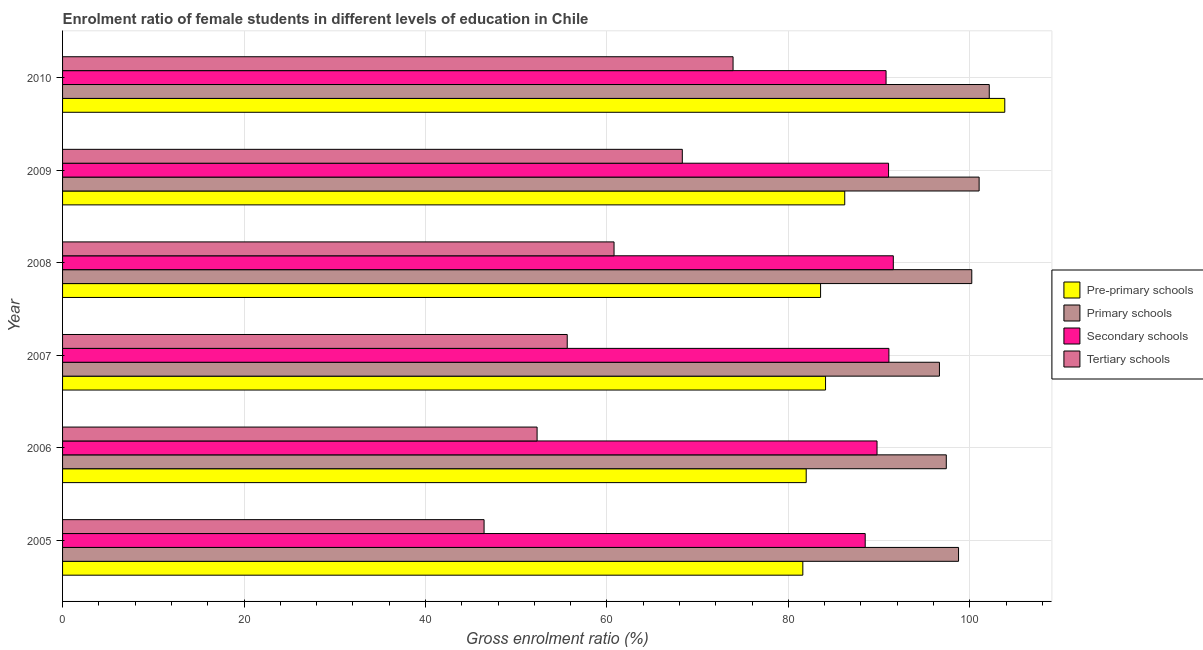Are the number of bars per tick equal to the number of legend labels?
Keep it short and to the point. Yes. How many bars are there on the 4th tick from the top?
Offer a very short reply. 4. What is the label of the 1st group of bars from the top?
Make the answer very short. 2010. In how many cases, is the number of bars for a given year not equal to the number of legend labels?
Your answer should be very brief. 0. What is the gross enrolment ratio(male) in pre-primary schools in 2006?
Give a very brief answer. 81.97. Across all years, what is the maximum gross enrolment ratio(male) in primary schools?
Keep it short and to the point. 102.15. Across all years, what is the minimum gross enrolment ratio(male) in primary schools?
Make the answer very short. 96.66. In which year was the gross enrolment ratio(male) in tertiary schools maximum?
Your answer should be very brief. 2010. In which year was the gross enrolment ratio(male) in secondary schools minimum?
Ensure brevity in your answer.  2005. What is the total gross enrolment ratio(male) in primary schools in the graph?
Give a very brief answer. 596.23. What is the difference between the gross enrolment ratio(male) in primary schools in 2005 and that in 2006?
Offer a very short reply. 1.35. What is the difference between the gross enrolment ratio(male) in secondary schools in 2005 and the gross enrolment ratio(male) in primary schools in 2010?
Offer a very short reply. -13.68. What is the average gross enrolment ratio(male) in tertiary schools per year?
Offer a very short reply. 59.57. In the year 2007, what is the difference between the gross enrolment ratio(male) in primary schools and gross enrolment ratio(male) in secondary schools?
Give a very brief answer. 5.57. What is the ratio of the gross enrolment ratio(male) in tertiary schools in 2005 to that in 2008?
Offer a terse response. 0.76. Is the difference between the gross enrolment ratio(male) in tertiary schools in 2008 and 2009 greater than the difference between the gross enrolment ratio(male) in primary schools in 2008 and 2009?
Provide a succinct answer. No. What is the difference between the highest and the second highest gross enrolment ratio(male) in pre-primary schools?
Your answer should be compact. 17.64. What is the difference between the highest and the lowest gross enrolment ratio(male) in tertiary schools?
Offer a very short reply. 27.44. In how many years, is the gross enrolment ratio(male) in secondary schools greater than the average gross enrolment ratio(male) in secondary schools taken over all years?
Offer a very short reply. 4. What does the 1st bar from the top in 2007 represents?
Offer a terse response. Tertiary schools. What does the 1st bar from the bottom in 2008 represents?
Your answer should be very brief. Pre-primary schools. How many years are there in the graph?
Keep it short and to the point. 6. What is the difference between two consecutive major ticks on the X-axis?
Your answer should be very brief. 20. Does the graph contain any zero values?
Your answer should be compact. No. How many legend labels are there?
Your answer should be compact. 4. How are the legend labels stacked?
Offer a terse response. Vertical. What is the title of the graph?
Ensure brevity in your answer.  Enrolment ratio of female students in different levels of education in Chile. Does "Revenue mobilization" appear as one of the legend labels in the graph?
Offer a very short reply. No. What is the label or title of the X-axis?
Your answer should be very brief. Gross enrolment ratio (%). What is the label or title of the Y-axis?
Offer a terse response. Year. What is the Gross enrolment ratio (%) of Pre-primary schools in 2005?
Your response must be concise. 81.6. What is the Gross enrolment ratio (%) in Primary schools in 2005?
Offer a very short reply. 98.76. What is the Gross enrolment ratio (%) in Secondary schools in 2005?
Your answer should be very brief. 88.47. What is the Gross enrolment ratio (%) of Tertiary schools in 2005?
Provide a succinct answer. 46.46. What is the Gross enrolment ratio (%) in Pre-primary schools in 2006?
Ensure brevity in your answer.  81.97. What is the Gross enrolment ratio (%) in Primary schools in 2006?
Provide a short and direct response. 97.41. What is the Gross enrolment ratio (%) in Secondary schools in 2006?
Ensure brevity in your answer.  89.78. What is the Gross enrolment ratio (%) of Tertiary schools in 2006?
Provide a succinct answer. 52.31. What is the Gross enrolment ratio (%) of Pre-primary schools in 2007?
Your answer should be compact. 84.1. What is the Gross enrolment ratio (%) in Primary schools in 2007?
Provide a short and direct response. 96.66. What is the Gross enrolment ratio (%) in Secondary schools in 2007?
Make the answer very short. 91.08. What is the Gross enrolment ratio (%) of Tertiary schools in 2007?
Your answer should be compact. 55.63. What is the Gross enrolment ratio (%) in Pre-primary schools in 2008?
Provide a succinct answer. 83.55. What is the Gross enrolment ratio (%) in Primary schools in 2008?
Offer a terse response. 100.22. What is the Gross enrolment ratio (%) of Secondary schools in 2008?
Give a very brief answer. 91.57. What is the Gross enrolment ratio (%) in Tertiary schools in 2008?
Your answer should be very brief. 60.79. What is the Gross enrolment ratio (%) in Pre-primary schools in 2009?
Provide a short and direct response. 86.22. What is the Gross enrolment ratio (%) in Primary schools in 2009?
Offer a terse response. 101.03. What is the Gross enrolment ratio (%) in Secondary schools in 2009?
Your answer should be very brief. 91.05. What is the Gross enrolment ratio (%) in Tertiary schools in 2009?
Make the answer very short. 68.31. What is the Gross enrolment ratio (%) of Pre-primary schools in 2010?
Make the answer very short. 103.86. What is the Gross enrolment ratio (%) of Primary schools in 2010?
Your answer should be compact. 102.15. What is the Gross enrolment ratio (%) of Secondary schools in 2010?
Provide a succinct answer. 90.77. What is the Gross enrolment ratio (%) in Tertiary schools in 2010?
Provide a succinct answer. 73.91. Across all years, what is the maximum Gross enrolment ratio (%) of Pre-primary schools?
Keep it short and to the point. 103.86. Across all years, what is the maximum Gross enrolment ratio (%) of Primary schools?
Offer a very short reply. 102.15. Across all years, what is the maximum Gross enrolment ratio (%) of Secondary schools?
Your answer should be compact. 91.57. Across all years, what is the maximum Gross enrolment ratio (%) in Tertiary schools?
Keep it short and to the point. 73.91. Across all years, what is the minimum Gross enrolment ratio (%) of Pre-primary schools?
Ensure brevity in your answer.  81.6. Across all years, what is the minimum Gross enrolment ratio (%) of Primary schools?
Keep it short and to the point. 96.66. Across all years, what is the minimum Gross enrolment ratio (%) in Secondary schools?
Your response must be concise. 88.47. Across all years, what is the minimum Gross enrolment ratio (%) of Tertiary schools?
Provide a short and direct response. 46.46. What is the total Gross enrolment ratio (%) in Pre-primary schools in the graph?
Keep it short and to the point. 521.3. What is the total Gross enrolment ratio (%) of Primary schools in the graph?
Ensure brevity in your answer.  596.23. What is the total Gross enrolment ratio (%) of Secondary schools in the graph?
Offer a very short reply. 542.72. What is the total Gross enrolment ratio (%) in Tertiary schools in the graph?
Your answer should be very brief. 357.41. What is the difference between the Gross enrolment ratio (%) in Pre-primary schools in 2005 and that in 2006?
Offer a terse response. -0.37. What is the difference between the Gross enrolment ratio (%) in Primary schools in 2005 and that in 2006?
Provide a succinct answer. 1.35. What is the difference between the Gross enrolment ratio (%) in Secondary schools in 2005 and that in 2006?
Ensure brevity in your answer.  -1.3. What is the difference between the Gross enrolment ratio (%) of Tertiary schools in 2005 and that in 2006?
Provide a succinct answer. -5.84. What is the difference between the Gross enrolment ratio (%) of Pre-primary schools in 2005 and that in 2007?
Offer a terse response. -2.5. What is the difference between the Gross enrolment ratio (%) in Primary schools in 2005 and that in 2007?
Offer a terse response. 2.11. What is the difference between the Gross enrolment ratio (%) in Secondary schools in 2005 and that in 2007?
Your answer should be very brief. -2.61. What is the difference between the Gross enrolment ratio (%) in Tertiary schools in 2005 and that in 2007?
Your response must be concise. -9.17. What is the difference between the Gross enrolment ratio (%) of Pre-primary schools in 2005 and that in 2008?
Your response must be concise. -1.96. What is the difference between the Gross enrolment ratio (%) of Primary schools in 2005 and that in 2008?
Offer a very short reply. -1.46. What is the difference between the Gross enrolment ratio (%) in Secondary schools in 2005 and that in 2008?
Make the answer very short. -3.1. What is the difference between the Gross enrolment ratio (%) in Tertiary schools in 2005 and that in 2008?
Provide a succinct answer. -14.33. What is the difference between the Gross enrolment ratio (%) of Pre-primary schools in 2005 and that in 2009?
Your answer should be compact. -4.62. What is the difference between the Gross enrolment ratio (%) in Primary schools in 2005 and that in 2009?
Ensure brevity in your answer.  -2.27. What is the difference between the Gross enrolment ratio (%) in Secondary schools in 2005 and that in 2009?
Your answer should be compact. -2.57. What is the difference between the Gross enrolment ratio (%) of Tertiary schools in 2005 and that in 2009?
Ensure brevity in your answer.  -21.85. What is the difference between the Gross enrolment ratio (%) in Pre-primary schools in 2005 and that in 2010?
Your answer should be very brief. -22.26. What is the difference between the Gross enrolment ratio (%) of Primary schools in 2005 and that in 2010?
Your response must be concise. -3.39. What is the difference between the Gross enrolment ratio (%) of Secondary schools in 2005 and that in 2010?
Offer a very short reply. -2.3. What is the difference between the Gross enrolment ratio (%) of Tertiary schools in 2005 and that in 2010?
Offer a terse response. -27.44. What is the difference between the Gross enrolment ratio (%) of Pre-primary schools in 2006 and that in 2007?
Give a very brief answer. -2.13. What is the difference between the Gross enrolment ratio (%) in Primary schools in 2006 and that in 2007?
Offer a terse response. 0.76. What is the difference between the Gross enrolment ratio (%) of Secondary schools in 2006 and that in 2007?
Provide a succinct answer. -1.31. What is the difference between the Gross enrolment ratio (%) of Tertiary schools in 2006 and that in 2007?
Offer a very short reply. -3.32. What is the difference between the Gross enrolment ratio (%) of Pre-primary schools in 2006 and that in 2008?
Offer a terse response. -1.58. What is the difference between the Gross enrolment ratio (%) of Primary schools in 2006 and that in 2008?
Keep it short and to the point. -2.81. What is the difference between the Gross enrolment ratio (%) in Secondary schools in 2006 and that in 2008?
Give a very brief answer. -1.79. What is the difference between the Gross enrolment ratio (%) of Tertiary schools in 2006 and that in 2008?
Ensure brevity in your answer.  -8.48. What is the difference between the Gross enrolment ratio (%) in Pre-primary schools in 2006 and that in 2009?
Your answer should be compact. -4.25. What is the difference between the Gross enrolment ratio (%) in Primary schools in 2006 and that in 2009?
Make the answer very short. -3.62. What is the difference between the Gross enrolment ratio (%) of Secondary schools in 2006 and that in 2009?
Give a very brief answer. -1.27. What is the difference between the Gross enrolment ratio (%) in Tertiary schools in 2006 and that in 2009?
Offer a very short reply. -16.01. What is the difference between the Gross enrolment ratio (%) in Pre-primary schools in 2006 and that in 2010?
Ensure brevity in your answer.  -21.89. What is the difference between the Gross enrolment ratio (%) of Primary schools in 2006 and that in 2010?
Make the answer very short. -4.74. What is the difference between the Gross enrolment ratio (%) of Secondary schools in 2006 and that in 2010?
Give a very brief answer. -1. What is the difference between the Gross enrolment ratio (%) in Tertiary schools in 2006 and that in 2010?
Provide a succinct answer. -21.6. What is the difference between the Gross enrolment ratio (%) of Pre-primary schools in 2007 and that in 2008?
Give a very brief answer. 0.55. What is the difference between the Gross enrolment ratio (%) of Primary schools in 2007 and that in 2008?
Keep it short and to the point. -3.56. What is the difference between the Gross enrolment ratio (%) in Secondary schools in 2007 and that in 2008?
Your response must be concise. -0.49. What is the difference between the Gross enrolment ratio (%) in Tertiary schools in 2007 and that in 2008?
Offer a terse response. -5.16. What is the difference between the Gross enrolment ratio (%) in Pre-primary schools in 2007 and that in 2009?
Ensure brevity in your answer.  -2.11. What is the difference between the Gross enrolment ratio (%) in Primary schools in 2007 and that in 2009?
Your answer should be compact. -4.37. What is the difference between the Gross enrolment ratio (%) of Secondary schools in 2007 and that in 2009?
Offer a very short reply. 0.04. What is the difference between the Gross enrolment ratio (%) of Tertiary schools in 2007 and that in 2009?
Provide a short and direct response. -12.69. What is the difference between the Gross enrolment ratio (%) in Pre-primary schools in 2007 and that in 2010?
Your answer should be very brief. -19.76. What is the difference between the Gross enrolment ratio (%) of Primary schools in 2007 and that in 2010?
Keep it short and to the point. -5.49. What is the difference between the Gross enrolment ratio (%) in Secondary schools in 2007 and that in 2010?
Give a very brief answer. 0.31. What is the difference between the Gross enrolment ratio (%) of Tertiary schools in 2007 and that in 2010?
Your answer should be compact. -18.28. What is the difference between the Gross enrolment ratio (%) in Pre-primary schools in 2008 and that in 2009?
Give a very brief answer. -2.66. What is the difference between the Gross enrolment ratio (%) of Primary schools in 2008 and that in 2009?
Offer a very short reply. -0.81. What is the difference between the Gross enrolment ratio (%) of Secondary schools in 2008 and that in 2009?
Your answer should be very brief. 0.52. What is the difference between the Gross enrolment ratio (%) in Tertiary schools in 2008 and that in 2009?
Your answer should be very brief. -7.53. What is the difference between the Gross enrolment ratio (%) of Pre-primary schools in 2008 and that in 2010?
Your answer should be very brief. -20.31. What is the difference between the Gross enrolment ratio (%) in Primary schools in 2008 and that in 2010?
Offer a very short reply. -1.93. What is the difference between the Gross enrolment ratio (%) in Secondary schools in 2008 and that in 2010?
Give a very brief answer. 0.8. What is the difference between the Gross enrolment ratio (%) of Tertiary schools in 2008 and that in 2010?
Keep it short and to the point. -13.12. What is the difference between the Gross enrolment ratio (%) in Pre-primary schools in 2009 and that in 2010?
Your answer should be compact. -17.64. What is the difference between the Gross enrolment ratio (%) in Primary schools in 2009 and that in 2010?
Offer a terse response. -1.12. What is the difference between the Gross enrolment ratio (%) of Secondary schools in 2009 and that in 2010?
Offer a very short reply. 0.28. What is the difference between the Gross enrolment ratio (%) of Tertiary schools in 2009 and that in 2010?
Offer a very short reply. -5.59. What is the difference between the Gross enrolment ratio (%) in Pre-primary schools in 2005 and the Gross enrolment ratio (%) in Primary schools in 2006?
Offer a terse response. -15.81. What is the difference between the Gross enrolment ratio (%) of Pre-primary schools in 2005 and the Gross enrolment ratio (%) of Secondary schools in 2006?
Your answer should be compact. -8.18. What is the difference between the Gross enrolment ratio (%) in Pre-primary schools in 2005 and the Gross enrolment ratio (%) in Tertiary schools in 2006?
Offer a very short reply. 29.29. What is the difference between the Gross enrolment ratio (%) of Primary schools in 2005 and the Gross enrolment ratio (%) of Secondary schools in 2006?
Provide a succinct answer. 8.99. What is the difference between the Gross enrolment ratio (%) of Primary schools in 2005 and the Gross enrolment ratio (%) of Tertiary schools in 2006?
Offer a terse response. 46.46. What is the difference between the Gross enrolment ratio (%) in Secondary schools in 2005 and the Gross enrolment ratio (%) in Tertiary schools in 2006?
Your response must be concise. 36.17. What is the difference between the Gross enrolment ratio (%) in Pre-primary schools in 2005 and the Gross enrolment ratio (%) in Primary schools in 2007?
Offer a very short reply. -15.06. What is the difference between the Gross enrolment ratio (%) of Pre-primary schools in 2005 and the Gross enrolment ratio (%) of Secondary schools in 2007?
Provide a short and direct response. -9.49. What is the difference between the Gross enrolment ratio (%) in Pre-primary schools in 2005 and the Gross enrolment ratio (%) in Tertiary schools in 2007?
Make the answer very short. 25.97. What is the difference between the Gross enrolment ratio (%) of Primary schools in 2005 and the Gross enrolment ratio (%) of Secondary schools in 2007?
Offer a terse response. 7.68. What is the difference between the Gross enrolment ratio (%) of Primary schools in 2005 and the Gross enrolment ratio (%) of Tertiary schools in 2007?
Offer a terse response. 43.13. What is the difference between the Gross enrolment ratio (%) in Secondary schools in 2005 and the Gross enrolment ratio (%) in Tertiary schools in 2007?
Provide a short and direct response. 32.84. What is the difference between the Gross enrolment ratio (%) in Pre-primary schools in 2005 and the Gross enrolment ratio (%) in Primary schools in 2008?
Provide a short and direct response. -18.62. What is the difference between the Gross enrolment ratio (%) in Pre-primary schools in 2005 and the Gross enrolment ratio (%) in Secondary schools in 2008?
Offer a very short reply. -9.97. What is the difference between the Gross enrolment ratio (%) of Pre-primary schools in 2005 and the Gross enrolment ratio (%) of Tertiary schools in 2008?
Make the answer very short. 20.81. What is the difference between the Gross enrolment ratio (%) in Primary schools in 2005 and the Gross enrolment ratio (%) in Secondary schools in 2008?
Keep it short and to the point. 7.19. What is the difference between the Gross enrolment ratio (%) in Primary schools in 2005 and the Gross enrolment ratio (%) in Tertiary schools in 2008?
Your answer should be very brief. 37.97. What is the difference between the Gross enrolment ratio (%) in Secondary schools in 2005 and the Gross enrolment ratio (%) in Tertiary schools in 2008?
Provide a short and direct response. 27.69. What is the difference between the Gross enrolment ratio (%) in Pre-primary schools in 2005 and the Gross enrolment ratio (%) in Primary schools in 2009?
Provide a succinct answer. -19.43. What is the difference between the Gross enrolment ratio (%) of Pre-primary schools in 2005 and the Gross enrolment ratio (%) of Secondary schools in 2009?
Provide a succinct answer. -9.45. What is the difference between the Gross enrolment ratio (%) of Pre-primary schools in 2005 and the Gross enrolment ratio (%) of Tertiary schools in 2009?
Your answer should be very brief. 13.28. What is the difference between the Gross enrolment ratio (%) in Primary schools in 2005 and the Gross enrolment ratio (%) in Secondary schools in 2009?
Keep it short and to the point. 7.71. What is the difference between the Gross enrolment ratio (%) of Primary schools in 2005 and the Gross enrolment ratio (%) of Tertiary schools in 2009?
Your answer should be compact. 30.45. What is the difference between the Gross enrolment ratio (%) of Secondary schools in 2005 and the Gross enrolment ratio (%) of Tertiary schools in 2009?
Ensure brevity in your answer.  20.16. What is the difference between the Gross enrolment ratio (%) of Pre-primary schools in 2005 and the Gross enrolment ratio (%) of Primary schools in 2010?
Offer a very short reply. -20.55. What is the difference between the Gross enrolment ratio (%) in Pre-primary schools in 2005 and the Gross enrolment ratio (%) in Secondary schools in 2010?
Give a very brief answer. -9.18. What is the difference between the Gross enrolment ratio (%) of Pre-primary schools in 2005 and the Gross enrolment ratio (%) of Tertiary schools in 2010?
Offer a terse response. 7.69. What is the difference between the Gross enrolment ratio (%) in Primary schools in 2005 and the Gross enrolment ratio (%) in Secondary schools in 2010?
Make the answer very short. 7.99. What is the difference between the Gross enrolment ratio (%) of Primary schools in 2005 and the Gross enrolment ratio (%) of Tertiary schools in 2010?
Offer a very short reply. 24.85. What is the difference between the Gross enrolment ratio (%) of Secondary schools in 2005 and the Gross enrolment ratio (%) of Tertiary schools in 2010?
Offer a terse response. 14.57. What is the difference between the Gross enrolment ratio (%) of Pre-primary schools in 2006 and the Gross enrolment ratio (%) of Primary schools in 2007?
Make the answer very short. -14.69. What is the difference between the Gross enrolment ratio (%) of Pre-primary schools in 2006 and the Gross enrolment ratio (%) of Secondary schools in 2007?
Provide a short and direct response. -9.11. What is the difference between the Gross enrolment ratio (%) in Pre-primary schools in 2006 and the Gross enrolment ratio (%) in Tertiary schools in 2007?
Your answer should be very brief. 26.34. What is the difference between the Gross enrolment ratio (%) in Primary schools in 2006 and the Gross enrolment ratio (%) in Secondary schools in 2007?
Your answer should be very brief. 6.33. What is the difference between the Gross enrolment ratio (%) in Primary schools in 2006 and the Gross enrolment ratio (%) in Tertiary schools in 2007?
Make the answer very short. 41.78. What is the difference between the Gross enrolment ratio (%) in Secondary schools in 2006 and the Gross enrolment ratio (%) in Tertiary schools in 2007?
Offer a terse response. 34.15. What is the difference between the Gross enrolment ratio (%) of Pre-primary schools in 2006 and the Gross enrolment ratio (%) of Primary schools in 2008?
Your response must be concise. -18.25. What is the difference between the Gross enrolment ratio (%) of Pre-primary schools in 2006 and the Gross enrolment ratio (%) of Secondary schools in 2008?
Offer a very short reply. -9.6. What is the difference between the Gross enrolment ratio (%) in Pre-primary schools in 2006 and the Gross enrolment ratio (%) in Tertiary schools in 2008?
Provide a short and direct response. 21.18. What is the difference between the Gross enrolment ratio (%) in Primary schools in 2006 and the Gross enrolment ratio (%) in Secondary schools in 2008?
Give a very brief answer. 5.84. What is the difference between the Gross enrolment ratio (%) in Primary schools in 2006 and the Gross enrolment ratio (%) in Tertiary schools in 2008?
Make the answer very short. 36.62. What is the difference between the Gross enrolment ratio (%) in Secondary schools in 2006 and the Gross enrolment ratio (%) in Tertiary schools in 2008?
Offer a terse response. 28.99. What is the difference between the Gross enrolment ratio (%) in Pre-primary schools in 2006 and the Gross enrolment ratio (%) in Primary schools in 2009?
Your answer should be very brief. -19.06. What is the difference between the Gross enrolment ratio (%) in Pre-primary schools in 2006 and the Gross enrolment ratio (%) in Secondary schools in 2009?
Provide a short and direct response. -9.08. What is the difference between the Gross enrolment ratio (%) in Pre-primary schools in 2006 and the Gross enrolment ratio (%) in Tertiary schools in 2009?
Your response must be concise. 13.66. What is the difference between the Gross enrolment ratio (%) of Primary schools in 2006 and the Gross enrolment ratio (%) of Secondary schools in 2009?
Provide a succinct answer. 6.36. What is the difference between the Gross enrolment ratio (%) of Primary schools in 2006 and the Gross enrolment ratio (%) of Tertiary schools in 2009?
Provide a succinct answer. 29.1. What is the difference between the Gross enrolment ratio (%) in Secondary schools in 2006 and the Gross enrolment ratio (%) in Tertiary schools in 2009?
Offer a terse response. 21.46. What is the difference between the Gross enrolment ratio (%) of Pre-primary schools in 2006 and the Gross enrolment ratio (%) of Primary schools in 2010?
Your answer should be compact. -20.18. What is the difference between the Gross enrolment ratio (%) in Pre-primary schools in 2006 and the Gross enrolment ratio (%) in Secondary schools in 2010?
Ensure brevity in your answer.  -8.8. What is the difference between the Gross enrolment ratio (%) of Pre-primary schools in 2006 and the Gross enrolment ratio (%) of Tertiary schools in 2010?
Ensure brevity in your answer.  8.06. What is the difference between the Gross enrolment ratio (%) in Primary schools in 2006 and the Gross enrolment ratio (%) in Secondary schools in 2010?
Provide a short and direct response. 6.64. What is the difference between the Gross enrolment ratio (%) of Primary schools in 2006 and the Gross enrolment ratio (%) of Tertiary schools in 2010?
Provide a short and direct response. 23.5. What is the difference between the Gross enrolment ratio (%) of Secondary schools in 2006 and the Gross enrolment ratio (%) of Tertiary schools in 2010?
Provide a succinct answer. 15.87. What is the difference between the Gross enrolment ratio (%) of Pre-primary schools in 2007 and the Gross enrolment ratio (%) of Primary schools in 2008?
Your answer should be very brief. -16.12. What is the difference between the Gross enrolment ratio (%) in Pre-primary schools in 2007 and the Gross enrolment ratio (%) in Secondary schools in 2008?
Your response must be concise. -7.47. What is the difference between the Gross enrolment ratio (%) of Pre-primary schools in 2007 and the Gross enrolment ratio (%) of Tertiary schools in 2008?
Ensure brevity in your answer.  23.31. What is the difference between the Gross enrolment ratio (%) of Primary schools in 2007 and the Gross enrolment ratio (%) of Secondary schools in 2008?
Your answer should be compact. 5.09. What is the difference between the Gross enrolment ratio (%) in Primary schools in 2007 and the Gross enrolment ratio (%) in Tertiary schools in 2008?
Your response must be concise. 35.87. What is the difference between the Gross enrolment ratio (%) in Secondary schools in 2007 and the Gross enrolment ratio (%) in Tertiary schools in 2008?
Your response must be concise. 30.3. What is the difference between the Gross enrolment ratio (%) in Pre-primary schools in 2007 and the Gross enrolment ratio (%) in Primary schools in 2009?
Ensure brevity in your answer.  -16.93. What is the difference between the Gross enrolment ratio (%) in Pre-primary schools in 2007 and the Gross enrolment ratio (%) in Secondary schools in 2009?
Keep it short and to the point. -6.95. What is the difference between the Gross enrolment ratio (%) in Pre-primary schools in 2007 and the Gross enrolment ratio (%) in Tertiary schools in 2009?
Offer a terse response. 15.79. What is the difference between the Gross enrolment ratio (%) in Primary schools in 2007 and the Gross enrolment ratio (%) in Secondary schools in 2009?
Your answer should be compact. 5.61. What is the difference between the Gross enrolment ratio (%) of Primary schools in 2007 and the Gross enrolment ratio (%) of Tertiary schools in 2009?
Offer a very short reply. 28.34. What is the difference between the Gross enrolment ratio (%) of Secondary schools in 2007 and the Gross enrolment ratio (%) of Tertiary schools in 2009?
Give a very brief answer. 22.77. What is the difference between the Gross enrolment ratio (%) in Pre-primary schools in 2007 and the Gross enrolment ratio (%) in Primary schools in 2010?
Make the answer very short. -18.05. What is the difference between the Gross enrolment ratio (%) in Pre-primary schools in 2007 and the Gross enrolment ratio (%) in Secondary schools in 2010?
Your response must be concise. -6.67. What is the difference between the Gross enrolment ratio (%) of Pre-primary schools in 2007 and the Gross enrolment ratio (%) of Tertiary schools in 2010?
Provide a short and direct response. 10.19. What is the difference between the Gross enrolment ratio (%) of Primary schools in 2007 and the Gross enrolment ratio (%) of Secondary schools in 2010?
Your answer should be compact. 5.88. What is the difference between the Gross enrolment ratio (%) in Primary schools in 2007 and the Gross enrolment ratio (%) in Tertiary schools in 2010?
Make the answer very short. 22.75. What is the difference between the Gross enrolment ratio (%) of Secondary schools in 2007 and the Gross enrolment ratio (%) of Tertiary schools in 2010?
Offer a very short reply. 17.18. What is the difference between the Gross enrolment ratio (%) of Pre-primary schools in 2008 and the Gross enrolment ratio (%) of Primary schools in 2009?
Your response must be concise. -17.48. What is the difference between the Gross enrolment ratio (%) of Pre-primary schools in 2008 and the Gross enrolment ratio (%) of Secondary schools in 2009?
Provide a succinct answer. -7.49. What is the difference between the Gross enrolment ratio (%) in Pre-primary schools in 2008 and the Gross enrolment ratio (%) in Tertiary schools in 2009?
Make the answer very short. 15.24. What is the difference between the Gross enrolment ratio (%) of Primary schools in 2008 and the Gross enrolment ratio (%) of Secondary schools in 2009?
Your response must be concise. 9.17. What is the difference between the Gross enrolment ratio (%) in Primary schools in 2008 and the Gross enrolment ratio (%) in Tertiary schools in 2009?
Provide a succinct answer. 31.91. What is the difference between the Gross enrolment ratio (%) of Secondary schools in 2008 and the Gross enrolment ratio (%) of Tertiary schools in 2009?
Ensure brevity in your answer.  23.26. What is the difference between the Gross enrolment ratio (%) of Pre-primary schools in 2008 and the Gross enrolment ratio (%) of Primary schools in 2010?
Your answer should be very brief. -18.6. What is the difference between the Gross enrolment ratio (%) of Pre-primary schools in 2008 and the Gross enrolment ratio (%) of Secondary schools in 2010?
Your answer should be compact. -7.22. What is the difference between the Gross enrolment ratio (%) in Pre-primary schools in 2008 and the Gross enrolment ratio (%) in Tertiary schools in 2010?
Offer a very short reply. 9.65. What is the difference between the Gross enrolment ratio (%) in Primary schools in 2008 and the Gross enrolment ratio (%) in Secondary schools in 2010?
Keep it short and to the point. 9.45. What is the difference between the Gross enrolment ratio (%) of Primary schools in 2008 and the Gross enrolment ratio (%) of Tertiary schools in 2010?
Keep it short and to the point. 26.31. What is the difference between the Gross enrolment ratio (%) of Secondary schools in 2008 and the Gross enrolment ratio (%) of Tertiary schools in 2010?
Ensure brevity in your answer.  17.66. What is the difference between the Gross enrolment ratio (%) of Pre-primary schools in 2009 and the Gross enrolment ratio (%) of Primary schools in 2010?
Give a very brief answer. -15.93. What is the difference between the Gross enrolment ratio (%) in Pre-primary schools in 2009 and the Gross enrolment ratio (%) in Secondary schools in 2010?
Make the answer very short. -4.56. What is the difference between the Gross enrolment ratio (%) of Pre-primary schools in 2009 and the Gross enrolment ratio (%) of Tertiary schools in 2010?
Your response must be concise. 12.31. What is the difference between the Gross enrolment ratio (%) of Primary schools in 2009 and the Gross enrolment ratio (%) of Secondary schools in 2010?
Your answer should be very brief. 10.26. What is the difference between the Gross enrolment ratio (%) in Primary schools in 2009 and the Gross enrolment ratio (%) in Tertiary schools in 2010?
Offer a very short reply. 27.12. What is the difference between the Gross enrolment ratio (%) in Secondary schools in 2009 and the Gross enrolment ratio (%) in Tertiary schools in 2010?
Offer a terse response. 17.14. What is the average Gross enrolment ratio (%) of Pre-primary schools per year?
Your answer should be compact. 86.88. What is the average Gross enrolment ratio (%) in Primary schools per year?
Offer a very short reply. 99.37. What is the average Gross enrolment ratio (%) of Secondary schools per year?
Your response must be concise. 90.45. What is the average Gross enrolment ratio (%) in Tertiary schools per year?
Offer a very short reply. 59.57. In the year 2005, what is the difference between the Gross enrolment ratio (%) of Pre-primary schools and Gross enrolment ratio (%) of Primary schools?
Offer a terse response. -17.17. In the year 2005, what is the difference between the Gross enrolment ratio (%) in Pre-primary schools and Gross enrolment ratio (%) in Secondary schools?
Offer a very short reply. -6.88. In the year 2005, what is the difference between the Gross enrolment ratio (%) in Pre-primary schools and Gross enrolment ratio (%) in Tertiary schools?
Your response must be concise. 35.13. In the year 2005, what is the difference between the Gross enrolment ratio (%) of Primary schools and Gross enrolment ratio (%) of Secondary schools?
Make the answer very short. 10.29. In the year 2005, what is the difference between the Gross enrolment ratio (%) in Primary schools and Gross enrolment ratio (%) in Tertiary schools?
Keep it short and to the point. 52.3. In the year 2005, what is the difference between the Gross enrolment ratio (%) of Secondary schools and Gross enrolment ratio (%) of Tertiary schools?
Offer a very short reply. 42.01. In the year 2006, what is the difference between the Gross enrolment ratio (%) of Pre-primary schools and Gross enrolment ratio (%) of Primary schools?
Offer a terse response. -15.44. In the year 2006, what is the difference between the Gross enrolment ratio (%) of Pre-primary schools and Gross enrolment ratio (%) of Secondary schools?
Your answer should be compact. -7.81. In the year 2006, what is the difference between the Gross enrolment ratio (%) of Pre-primary schools and Gross enrolment ratio (%) of Tertiary schools?
Provide a short and direct response. 29.66. In the year 2006, what is the difference between the Gross enrolment ratio (%) in Primary schools and Gross enrolment ratio (%) in Secondary schools?
Ensure brevity in your answer.  7.63. In the year 2006, what is the difference between the Gross enrolment ratio (%) in Primary schools and Gross enrolment ratio (%) in Tertiary schools?
Your response must be concise. 45.1. In the year 2006, what is the difference between the Gross enrolment ratio (%) of Secondary schools and Gross enrolment ratio (%) of Tertiary schools?
Give a very brief answer. 37.47. In the year 2007, what is the difference between the Gross enrolment ratio (%) in Pre-primary schools and Gross enrolment ratio (%) in Primary schools?
Your answer should be very brief. -12.55. In the year 2007, what is the difference between the Gross enrolment ratio (%) of Pre-primary schools and Gross enrolment ratio (%) of Secondary schools?
Make the answer very short. -6.98. In the year 2007, what is the difference between the Gross enrolment ratio (%) in Pre-primary schools and Gross enrolment ratio (%) in Tertiary schools?
Provide a short and direct response. 28.47. In the year 2007, what is the difference between the Gross enrolment ratio (%) in Primary schools and Gross enrolment ratio (%) in Secondary schools?
Provide a short and direct response. 5.57. In the year 2007, what is the difference between the Gross enrolment ratio (%) in Primary schools and Gross enrolment ratio (%) in Tertiary schools?
Offer a very short reply. 41.03. In the year 2007, what is the difference between the Gross enrolment ratio (%) of Secondary schools and Gross enrolment ratio (%) of Tertiary schools?
Your response must be concise. 35.46. In the year 2008, what is the difference between the Gross enrolment ratio (%) of Pre-primary schools and Gross enrolment ratio (%) of Primary schools?
Provide a short and direct response. -16.67. In the year 2008, what is the difference between the Gross enrolment ratio (%) of Pre-primary schools and Gross enrolment ratio (%) of Secondary schools?
Make the answer very short. -8.02. In the year 2008, what is the difference between the Gross enrolment ratio (%) in Pre-primary schools and Gross enrolment ratio (%) in Tertiary schools?
Ensure brevity in your answer.  22.77. In the year 2008, what is the difference between the Gross enrolment ratio (%) in Primary schools and Gross enrolment ratio (%) in Secondary schools?
Ensure brevity in your answer.  8.65. In the year 2008, what is the difference between the Gross enrolment ratio (%) in Primary schools and Gross enrolment ratio (%) in Tertiary schools?
Make the answer very short. 39.43. In the year 2008, what is the difference between the Gross enrolment ratio (%) in Secondary schools and Gross enrolment ratio (%) in Tertiary schools?
Provide a short and direct response. 30.78. In the year 2009, what is the difference between the Gross enrolment ratio (%) in Pre-primary schools and Gross enrolment ratio (%) in Primary schools?
Provide a succinct answer. -14.81. In the year 2009, what is the difference between the Gross enrolment ratio (%) in Pre-primary schools and Gross enrolment ratio (%) in Secondary schools?
Make the answer very short. -4.83. In the year 2009, what is the difference between the Gross enrolment ratio (%) in Pre-primary schools and Gross enrolment ratio (%) in Tertiary schools?
Make the answer very short. 17.9. In the year 2009, what is the difference between the Gross enrolment ratio (%) in Primary schools and Gross enrolment ratio (%) in Secondary schools?
Offer a very short reply. 9.98. In the year 2009, what is the difference between the Gross enrolment ratio (%) of Primary schools and Gross enrolment ratio (%) of Tertiary schools?
Your answer should be compact. 32.72. In the year 2009, what is the difference between the Gross enrolment ratio (%) in Secondary schools and Gross enrolment ratio (%) in Tertiary schools?
Offer a very short reply. 22.73. In the year 2010, what is the difference between the Gross enrolment ratio (%) in Pre-primary schools and Gross enrolment ratio (%) in Primary schools?
Your answer should be very brief. 1.71. In the year 2010, what is the difference between the Gross enrolment ratio (%) in Pre-primary schools and Gross enrolment ratio (%) in Secondary schools?
Provide a succinct answer. 13.09. In the year 2010, what is the difference between the Gross enrolment ratio (%) of Pre-primary schools and Gross enrolment ratio (%) of Tertiary schools?
Make the answer very short. 29.95. In the year 2010, what is the difference between the Gross enrolment ratio (%) in Primary schools and Gross enrolment ratio (%) in Secondary schools?
Ensure brevity in your answer.  11.38. In the year 2010, what is the difference between the Gross enrolment ratio (%) of Primary schools and Gross enrolment ratio (%) of Tertiary schools?
Provide a short and direct response. 28.24. In the year 2010, what is the difference between the Gross enrolment ratio (%) of Secondary schools and Gross enrolment ratio (%) of Tertiary schools?
Your answer should be very brief. 16.86. What is the ratio of the Gross enrolment ratio (%) of Primary schools in 2005 to that in 2006?
Offer a very short reply. 1.01. What is the ratio of the Gross enrolment ratio (%) in Secondary schools in 2005 to that in 2006?
Provide a succinct answer. 0.99. What is the ratio of the Gross enrolment ratio (%) of Tertiary schools in 2005 to that in 2006?
Ensure brevity in your answer.  0.89. What is the ratio of the Gross enrolment ratio (%) in Pre-primary schools in 2005 to that in 2007?
Give a very brief answer. 0.97. What is the ratio of the Gross enrolment ratio (%) of Primary schools in 2005 to that in 2007?
Your answer should be compact. 1.02. What is the ratio of the Gross enrolment ratio (%) in Secondary schools in 2005 to that in 2007?
Keep it short and to the point. 0.97. What is the ratio of the Gross enrolment ratio (%) of Tertiary schools in 2005 to that in 2007?
Offer a terse response. 0.84. What is the ratio of the Gross enrolment ratio (%) of Pre-primary schools in 2005 to that in 2008?
Provide a short and direct response. 0.98. What is the ratio of the Gross enrolment ratio (%) in Primary schools in 2005 to that in 2008?
Provide a short and direct response. 0.99. What is the ratio of the Gross enrolment ratio (%) of Secondary schools in 2005 to that in 2008?
Keep it short and to the point. 0.97. What is the ratio of the Gross enrolment ratio (%) in Tertiary schools in 2005 to that in 2008?
Keep it short and to the point. 0.76. What is the ratio of the Gross enrolment ratio (%) in Pre-primary schools in 2005 to that in 2009?
Make the answer very short. 0.95. What is the ratio of the Gross enrolment ratio (%) in Primary schools in 2005 to that in 2009?
Keep it short and to the point. 0.98. What is the ratio of the Gross enrolment ratio (%) of Secondary schools in 2005 to that in 2009?
Ensure brevity in your answer.  0.97. What is the ratio of the Gross enrolment ratio (%) in Tertiary schools in 2005 to that in 2009?
Keep it short and to the point. 0.68. What is the ratio of the Gross enrolment ratio (%) of Pre-primary schools in 2005 to that in 2010?
Provide a short and direct response. 0.79. What is the ratio of the Gross enrolment ratio (%) of Primary schools in 2005 to that in 2010?
Provide a succinct answer. 0.97. What is the ratio of the Gross enrolment ratio (%) in Secondary schools in 2005 to that in 2010?
Keep it short and to the point. 0.97. What is the ratio of the Gross enrolment ratio (%) in Tertiary schools in 2005 to that in 2010?
Make the answer very short. 0.63. What is the ratio of the Gross enrolment ratio (%) of Pre-primary schools in 2006 to that in 2007?
Ensure brevity in your answer.  0.97. What is the ratio of the Gross enrolment ratio (%) in Secondary schools in 2006 to that in 2007?
Make the answer very short. 0.99. What is the ratio of the Gross enrolment ratio (%) in Tertiary schools in 2006 to that in 2007?
Make the answer very short. 0.94. What is the ratio of the Gross enrolment ratio (%) in Secondary schools in 2006 to that in 2008?
Offer a terse response. 0.98. What is the ratio of the Gross enrolment ratio (%) in Tertiary schools in 2006 to that in 2008?
Keep it short and to the point. 0.86. What is the ratio of the Gross enrolment ratio (%) of Pre-primary schools in 2006 to that in 2009?
Make the answer very short. 0.95. What is the ratio of the Gross enrolment ratio (%) in Primary schools in 2006 to that in 2009?
Your answer should be very brief. 0.96. What is the ratio of the Gross enrolment ratio (%) in Tertiary schools in 2006 to that in 2009?
Make the answer very short. 0.77. What is the ratio of the Gross enrolment ratio (%) in Pre-primary schools in 2006 to that in 2010?
Your answer should be compact. 0.79. What is the ratio of the Gross enrolment ratio (%) in Primary schools in 2006 to that in 2010?
Offer a very short reply. 0.95. What is the ratio of the Gross enrolment ratio (%) of Secondary schools in 2006 to that in 2010?
Offer a terse response. 0.99. What is the ratio of the Gross enrolment ratio (%) of Tertiary schools in 2006 to that in 2010?
Ensure brevity in your answer.  0.71. What is the ratio of the Gross enrolment ratio (%) in Pre-primary schools in 2007 to that in 2008?
Ensure brevity in your answer.  1.01. What is the ratio of the Gross enrolment ratio (%) of Primary schools in 2007 to that in 2008?
Make the answer very short. 0.96. What is the ratio of the Gross enrolment ratio (%) in Secondary schools in 2007 to that in 2008?
Your answer should be compact. 0.99. What is the ratio of the Gross enrolment ratio (%) in Tertiary schools in 2007 to that in 2008?
Your response must be concise. 0.92. What is the ratio of the Gross enrolment ratio (%) in Pre-primary schools in 2007 to that in 2009?
Your response must be concise. 0.98. What is the ratio of the Gross enrolment ratio (%) of Primary schools in 2007 to that in 2009?
Keep it short and to the point. 0.96. What is the ratio of the Gross enrolment ratio (%) of Secondary schools in 2007 to that in 2009?
Your response must be concise. 1. What is the ratio of the Gross enrolment ratio (%) of Tertiary schools in 2007 to that in 2009?
Offer a very short reply. 0.81. What is the ratio of the Gross enrolment ratio (%) in Pre-primary schools in 2007 to that in 2010?
Provide a succinct answer. 0.81. What is the ratio of the Gross enrolment ratio (%) of Primary schools in 2007 to that in 2010?
Keep it short and to the point. 0.95. What is the ratio of the Gross enrolment ratio (%) in Tertiary schools in 2007 to that in 2010?
Your answer should be very brief. 0.75. What is the ratio of the Gross enrolment ratio (%) of Pre-primary schools in 2008 to that in 2009?
Give a very brief answer. 0.97. What is the ratio of the Gross enrolment ratio (%) of Primary schools in 2008 to that in 2009?
Your answer should be compact. 0.99. What is the ratio of the Gross enrolment ratio (%) in Tertiary schools in 2008 to that in 2009?
Make the answer very short. 0.89. What is the ratio of the Gross enrolment ratio (%) in Pre-primary schools in 2008 to that in 2010?
Your answer should be very brief. 0.8. What is the ratio of the Gross enrolment ratio (%) of Primary schools in 2008 to that in 2010?
Keep it short and to the point. 0.98. What is the ratio of the Gross enrolment ratio (%) in Secondary schools in 2008 to that in 2010?
Give a very brief answer. 1.01. What is the ratio of the Gross enrolment ratio (%) in Tertiary schools in 2008 to that in 2010?
Offer a terse response. 0.82. What is the ratio of the Gross enrolment ratio (%) of Pre-primary schools in 2009 to that in 2010?
Keep it short and to the point. 0.83. What is the ratio of the Gross enrolment ratio (%) of Tertiary schools in 2009 to that in 2010?
Your response must be concise. 0.92. What is the difference between the highest and the second highest Gross enrolment ratio (%) of Pre-primary schools?
Provide a succinct answer. 17.64. What is the difference between the highest and the second highest Gross enrolment ratio (%) in Primary schools?
Provide a succinct answer. 1.12. What is the difference between the highest and the second highest Gross enrolment ratio (%) in Secondary schools?
Offer a very short reply. 0.49. What is the difference between the highest and the second highest Gross enrolment ratio (%) in Tertiary schools?
Give a very brief answer. 5.59. What is the difference between the highest and the lowest Gross enrolment ratio (%) of Pre-primary schools?
Your answer should be compact. 22.26. What is the difference between the highest and the lowest Gross enrolment ratio (%) in Primary schools?
Give a very brief answer. 5.49. What is the difference between the highest and the lowest Gross enrolment ratio (%) in Secondary schools?
Provide a succinct answer. 3.1. What is the difference between the highest and the lowest Gross enrolment ratio (%) of Tertiary schools?
Provide a short and direct response. 27.44. 